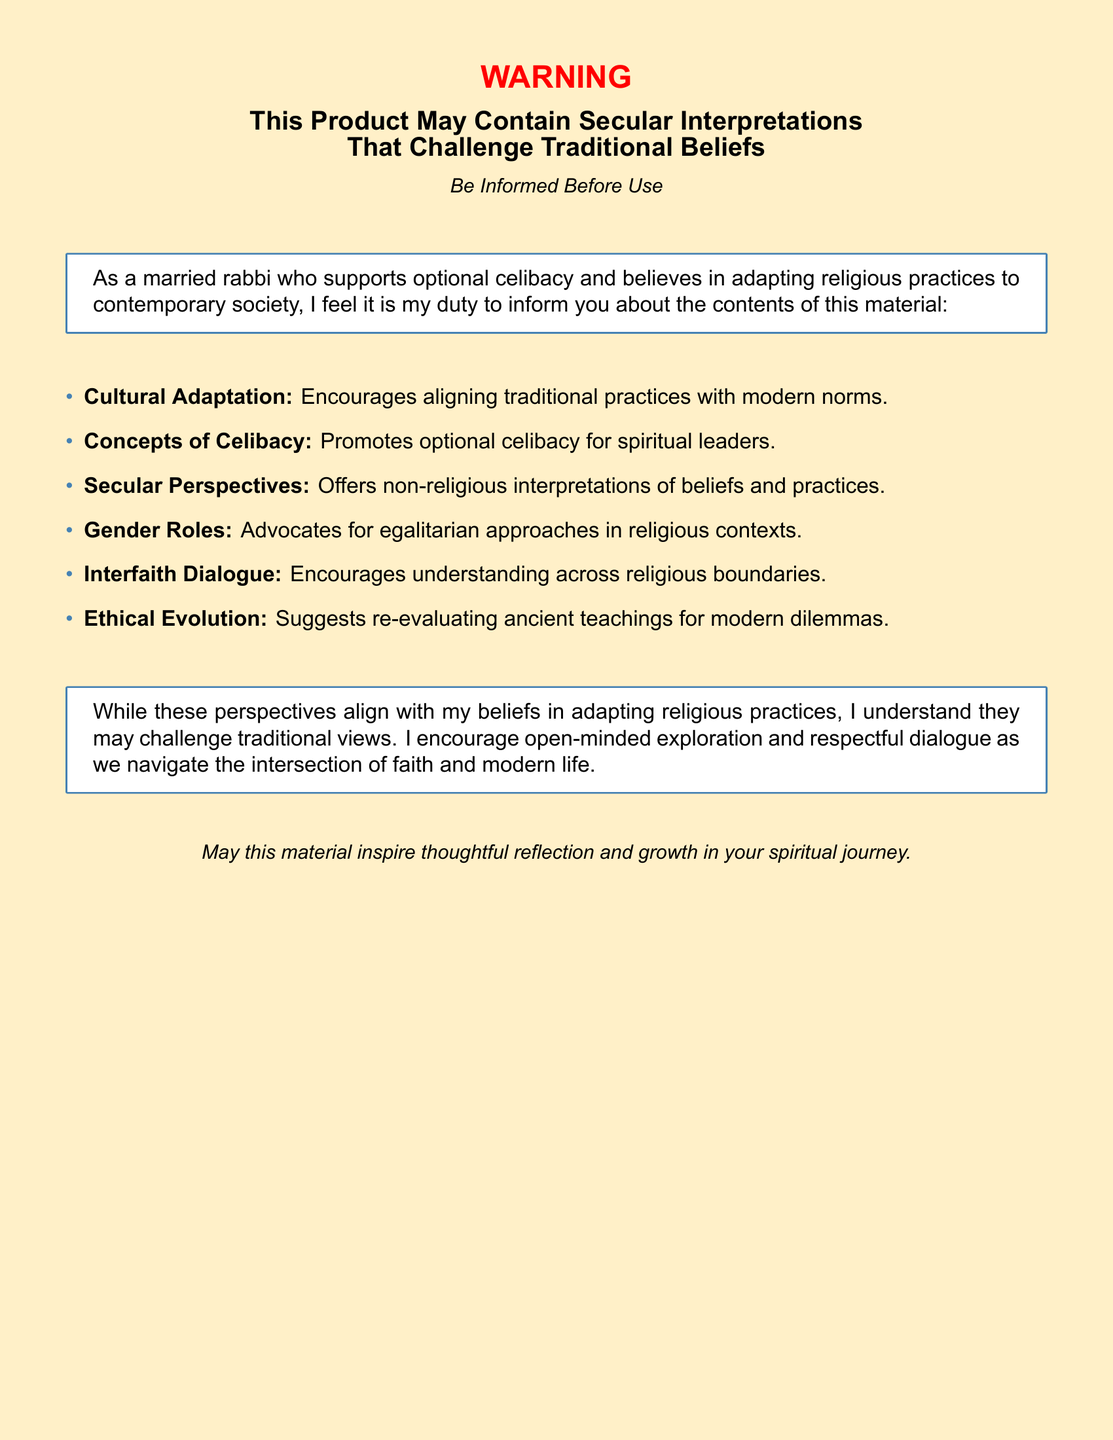What is the main color of the warning label? The main color of the warning label background is described in the document as a light yellowish tone.
Answer: Warning color What does the warning label caution about? The document cautions that the product may contain interpretations that contradict traditional beliefs.
Answer: Secular interpretations Who is the author of the warning label? The warning label is authored by a married rabbi who supports certain modern adaptations in religion.
Answer: A married rabbi What concept related to celibacy is promoted in the document? The document promotes the idea of optional celibacy specifically for spiritual leaders.
Answer: Optional celibacy How does the document suggest we approach ancient teachings? It suggests re-evaluating ancient teachings to address modern dilemmas, advocating for ethical evolution.
Answer: Ethical evolution What kind of dialogue does the document encourage? The document encourages interfaith dialogue to foster understanding across different religious beliefs.
Answer: Interfaith dialogue What is suggested regarding gender roles in the document? The document advocates for egalitarian approaches in religious contexts concerning gender roles.
Answer: Egalitarian approaches What is the overall tone of the warning label? The overall tone encourages open-minded exploration and respectful dialogue on faith and modernity.
Answer: Encouraging tone 